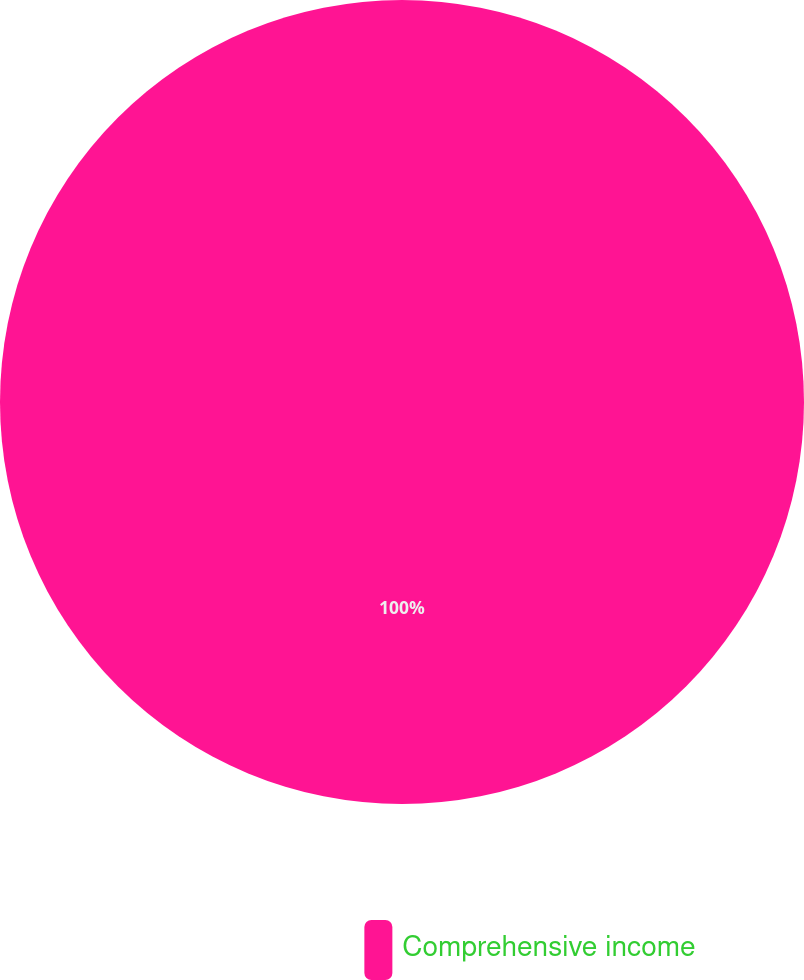<chart> <loc_0><loc_0><loc_500><loc_500><pie_chart><fcel>Comprehensive income<nl><fcel>100.0%<nl></chart> 